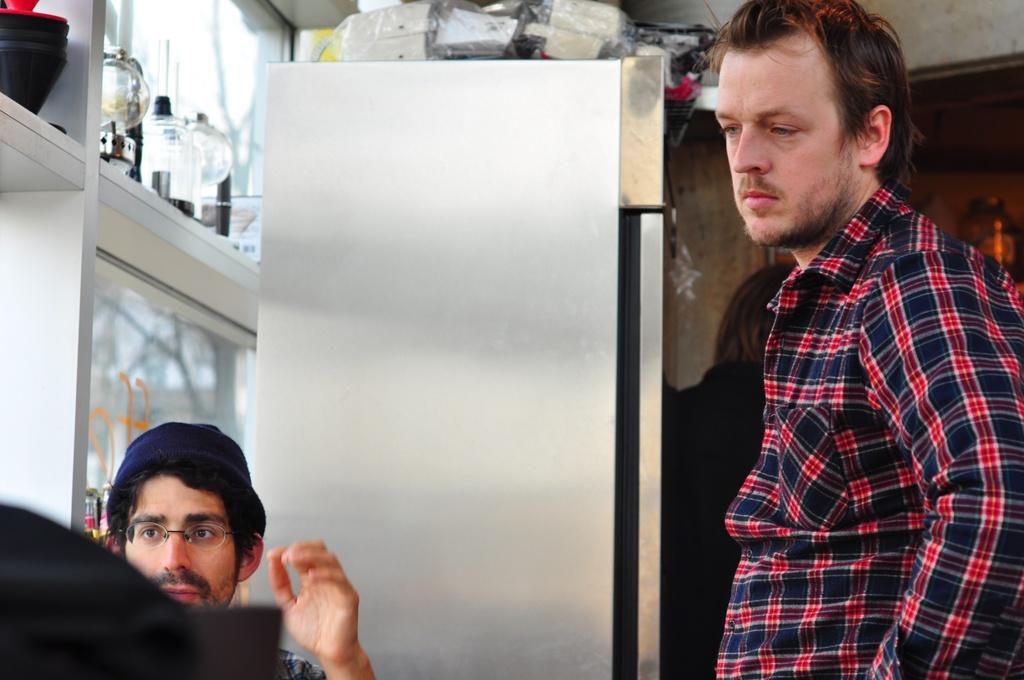What is located in front of the glass windows in the image? The provided facts do not specify what objects are in front of the glass windows. What can be found above the fridge in the image? The provided facts do not specify what things are above the fridge. How many people are visible in the image? There are three people visible in the image. How many pigs are visible in the image? There are no pigs present in the image. What is the color of the bit that the person is using to kick the object in the image? There is no bit or object being kicked in the image. 